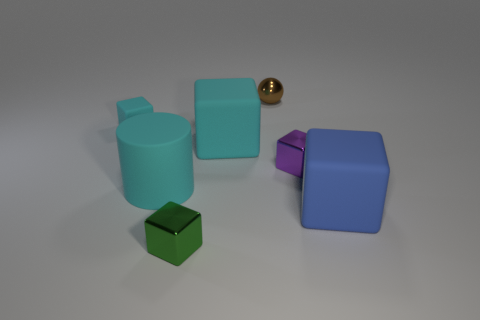There is a cube that is in front of the blue block; is it the same size as the cyan object right of the tiny green cube?
Ensure brevity in your answer.  No. Is there a tiny green cube that has the same material as the tiny ball?
Your answer should be compact. Yes. How many things are either tiny metal cubes that are in front of the tiny purple metallic cube or big purple metal spheres?
Your answer should be compact. 1. Are the tiny block that is in front of the cyan cylinder and the large cyan block made of the same material?
Offer a terse response. No. Is the shape of the large blue object the same as the green metallic object?
Make the answer very short. Yes. What number of purple objects are in front of the metal object that is to the left of the tiny brown ball?
Provide a succinct answer. 0. What is the material of the purple thing that is the same shape as the tiny green thing?
Keep it short and to the point. Metal. Does the tiny rubber object behind the purple thing have the same color as the big matte cylinder?
Make the answer very short. Yes. Does the cylinder have the same material as the big cube behind the blue matte thing?
Provide a short and direct response. Yes. What shape is the big matte thing that is to the right of the purple cube?
Ensure brevity in your answer.  Cube. 